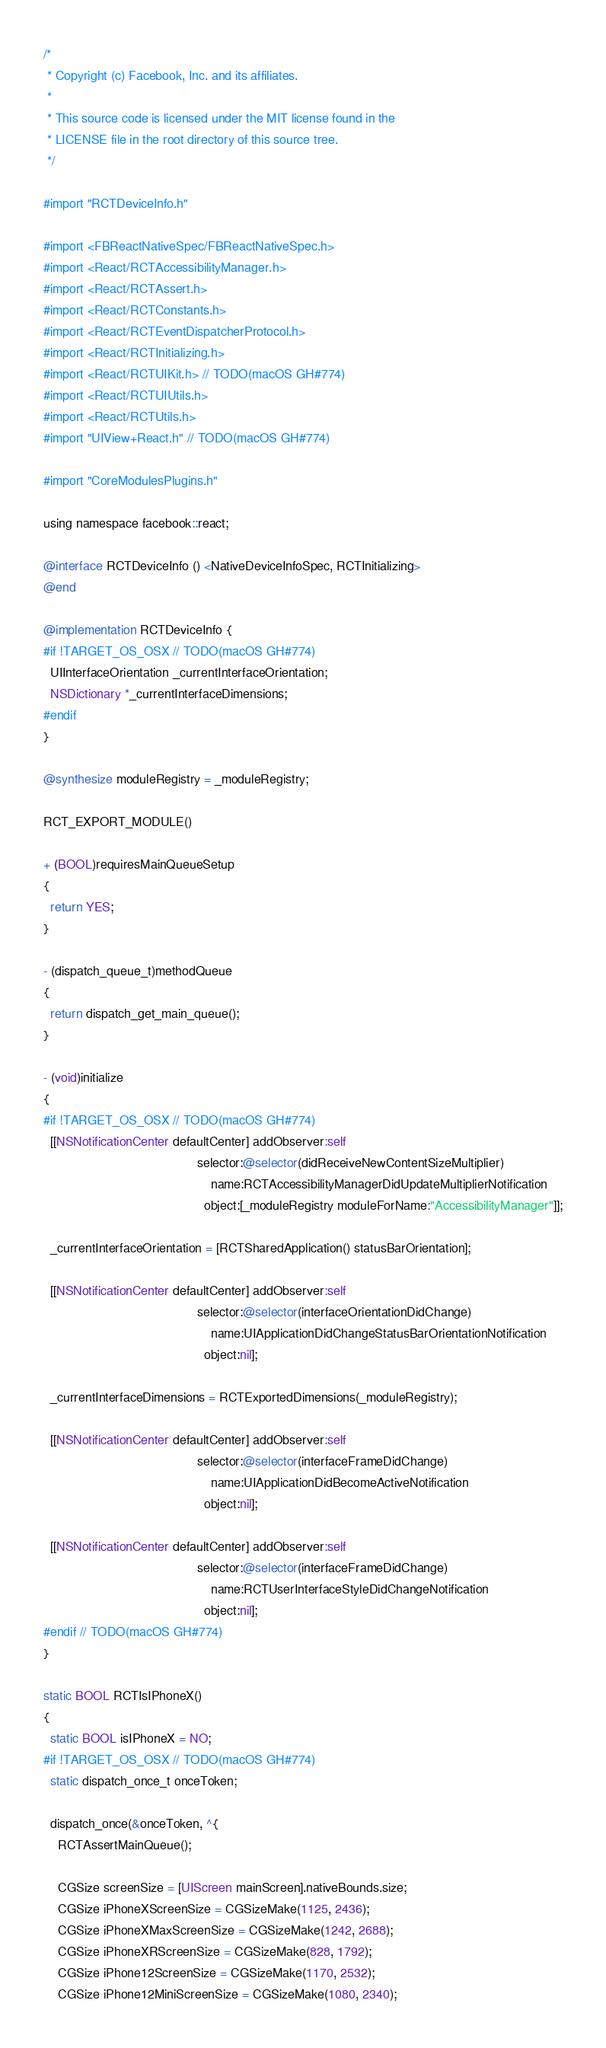<code> <loc_0><loc_0><loc_500><loc_500><_ObjectiveC_>/*
 * Copyright (c) Facebook, Inc. and its affiliates.
 *
 * This source code is licensed under the MIT license found in the
 * LICENSE file in the root directory of this source tree.
 */

#import "RCTDeviceInfo.h"

#import <FBReactNativeSpec/FBReactNativeSpec.h>
#import <React/RCTAccessibilityManager.h>
#import <React/RCTAssert.h>
#import <React/RCTConstants.h>
#import <React/RCTEventDispatcherProtocol.h>
#import <React/RCTInitializing.h>
#import <React/RCTUIKit.h> // TODO(macOS GH#774)
#import <React/RCTUIUtils.h>
#import <React/RCTUtils.h>
#import "UIView+React.h" // TODO(macOS GH#774)

#import "CoreModulesPlugins.h"

using namespace facebook::react;

@interface RCTDeviceInfo () <NativeDeviceInfoSpec, RCTInitializing>
@end

@implementation RCTDeviceInfo {
#if !TARGET_OS_OSX // TODO(macOS GH#774)
  UIInterfaceOrientation _currentInterfaceOrientation;
  NSDictionary *_currentInterfaceDimensions;
#endif
}

@synthesize moduleRegistry = _moduleRegistry;

RCT_EXPORT_MODULE()

+ (BOOL)requiresMainQueueSetup
{
  return YES;
}

- (dispatch_queue_t)methodQueue
{
  return dispatch_get_main_queue();
}

- (void)initialize
{
#if !TARGET_OS_OSX // TODO(macOS GH#774)
  [[NSNotificationCenter defaultCenter] addObserver:self
                                           selector:@selector(didReceiveNewContentSizeMultiplier)
                                               name:RCTAccessibilityManagerDidUpdateMultiplierNotification
                                             object:[_moduleRegistry moduleForName:"AccessibilityManager"]];

  _currentInterfaceOrientation = [RCTSharedApplication() statusBarOrientation];

  [[NSNotificationCenter defaultCenter] addObserver:self
                                           selector:@selector(interfaceOrientationDidChange)
                                               name:UIApplicationDidChangeStatusBarOrientationNotification
                                             object:nil];

  _currentInterfaceDimensions = RCTExportedDimensions(_moduleRegistry);

  [[NSNotificationCenter defaultCenter] addObserver:self
                                           selector:@selector(interfaceFrameDidChange)
                                               name:UIApplicationDidBecomeActiveNotification
                                             object:nil];

  [[NSNotificationCenter defaultCenter] addObserver:self
                                           selector:@selector(interfaceFrameDidChange)
                                               name:RCTUserInterfaceStyleDidChangeNotification
                                             object:nil];
#endif // TODO(macOS GH#774)
}

static BOOL RCTIsIPhoneX()
{
  static BOOL isIPhoneX = NO;
#if !TARGET_OS_OSX // TODO(macOS GH#774)
  static dispatch_once_t onceToken;

  dispatch_once(&onceToken, ^{
    RCTAssertMainQueue();

    CGSize screenSize = [UIScreen mainScreen].nativeBounds.size;
    CGSize iPhoneXScreenSize = CGSizeMake(1125, 2436);
    CGSize iPhoneXMaxScreenSize = CGSizeMake(1242, 2688);
    CGSize iPhoneXRScreenSize = CGSizeMake(828, 1792);
    CGSize iPhone12ScreenSize = CGSizeMake(1170, 2532);
    CGSize iPhone12MiniScreenSize = CGSizeMake(1080, 2340);</code> 